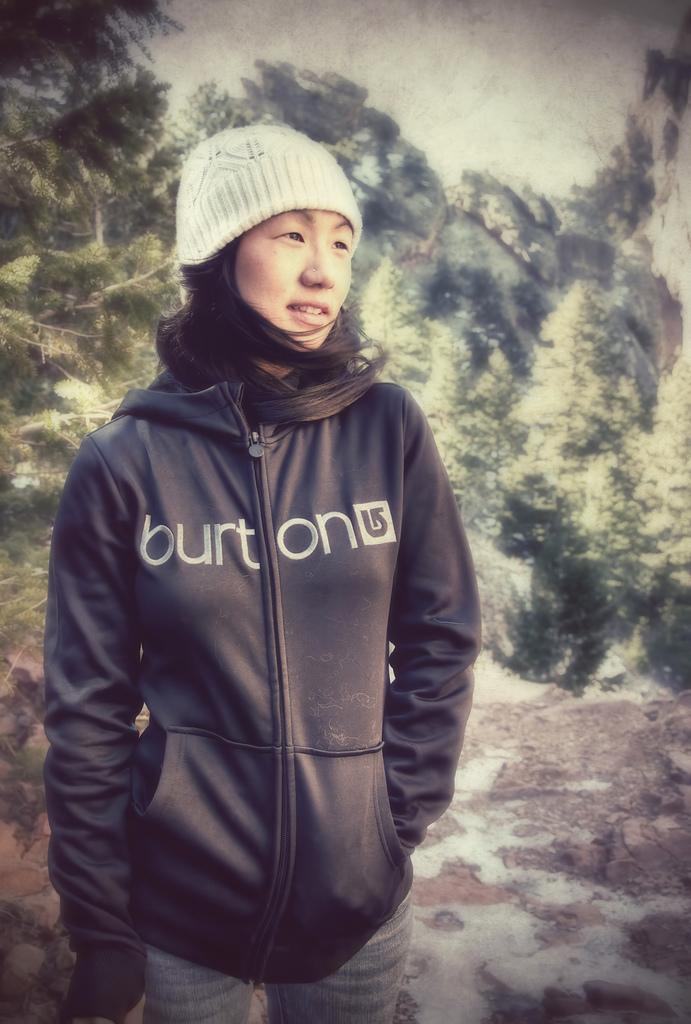How would you summarize this image in a sentence or two? In the center of the image we can see one woman standing and she is smiling, which we can see on her face. And we can see she is wearing a hat and a jacket. And we can see some text on the jacket. In the background we can see trees, stones and a few other objects. 